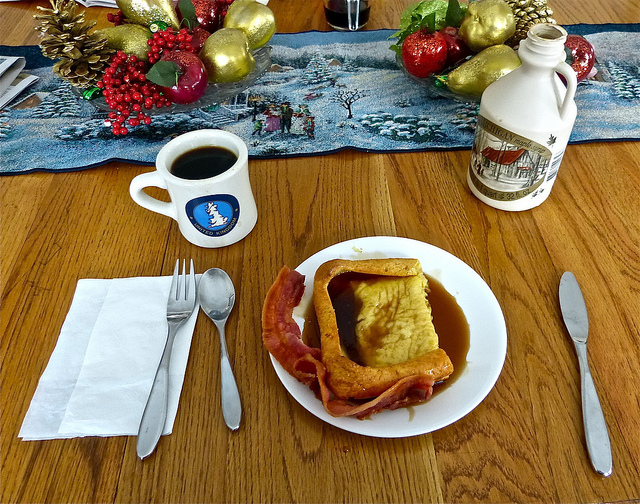<image>In which season was this photo taken? I am not sure in which season this photo was taken. The answers vary between summer, winter and fall. In which season was this photo taken? I don't know which season this photo was taken in. It could be winter, fall, summer, or unknown. 